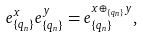<formula> <loc_0><loc_0><loc_500><loc_500>e _ { \{ q _ { n } \} } ^ { x } e _ { \{ q _ { n } \} } ^ { y } = e _ { \{ q _ { n } \} } ^ { x \oplus _ { \{ q _ { n } \} } y } ,</formula> 